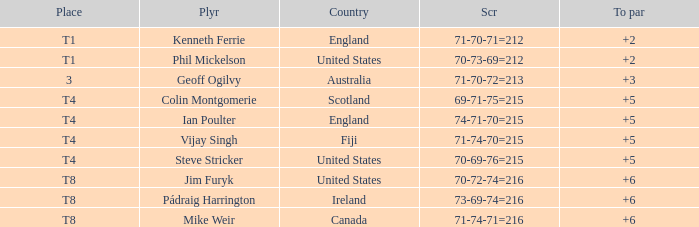What score to highest to par did Mike Weir achieve? 6.0. 